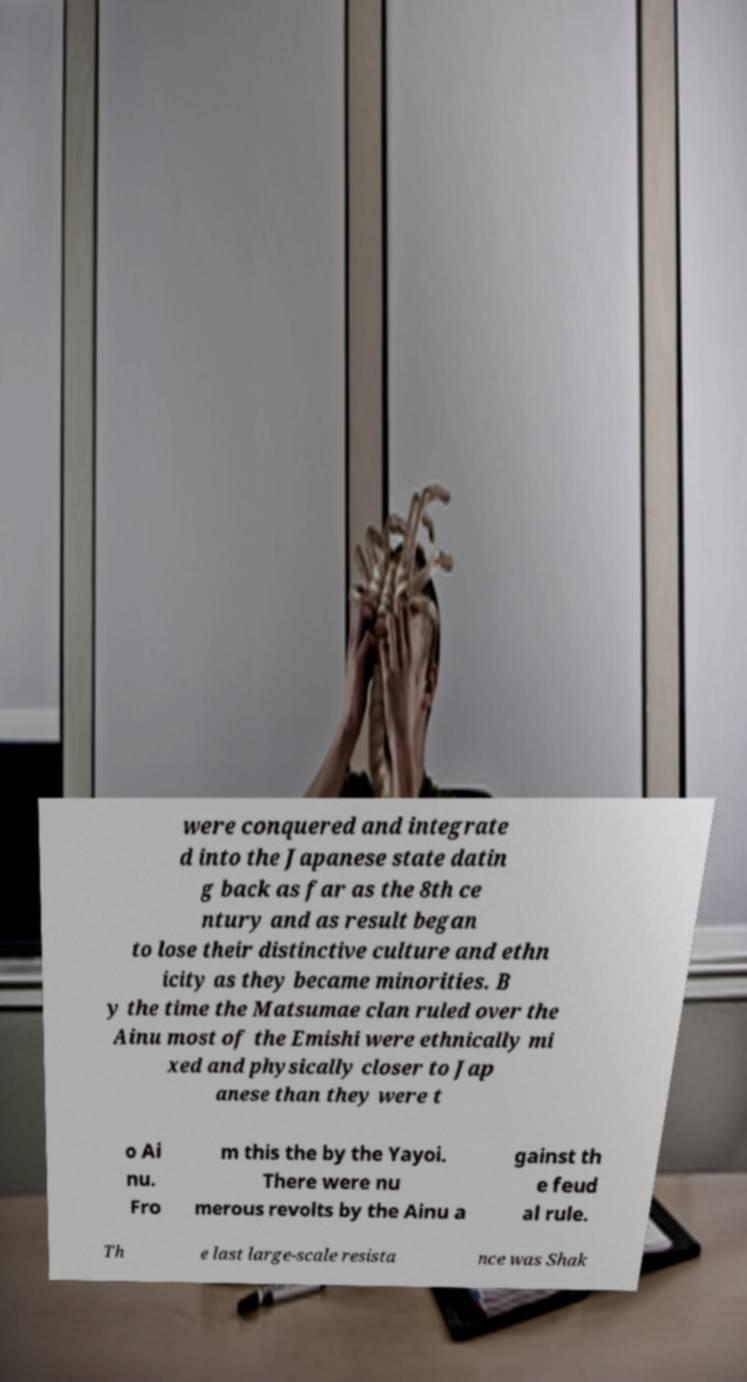Can you read and provide the text displayed in the image?This photo seems to have some interesting text. Can you extract and type it out for me? were conquered and integrate d into the Japanese state datin g back as far as the 8th ce ntury and as result began to lose their distinctive culture and ethn icity as they became minorities. B y the time the Matsumae clan ruled over the Ainu most of the Emishi were ethnically mi xed and physically closer to Jap anese than they were t o Ai nu. Fro m this the by the Yayoi. There were nu merous revolts by the Ainu a gainst th e feud al rule. Th e last large-scale resista nce was Shak 